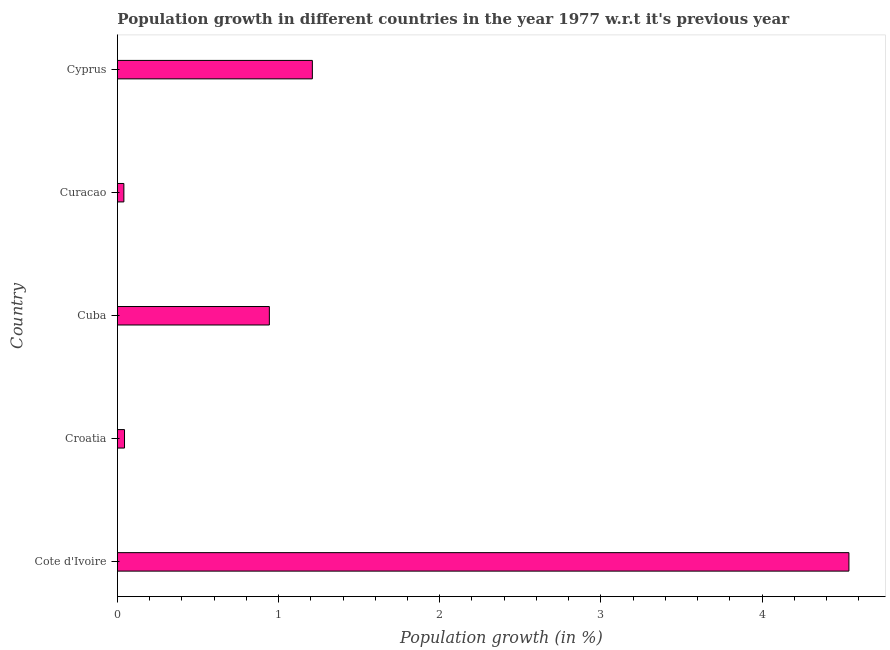Does the graph contain any zero values?
Provide a succinct answer. No. Does the graph contain grids?
Offer a terse response. No. What is the title of the graph?
Make the answer very short. Population growth in different countries in the year 1977 w.r.t it's previous year. What is the label or title of the X-axis?
Your answer should be compact. Population growth (in %). What is the label or title of the Y-axis?
Provide a succinct answer. Country. What is the population growth in Cuba?
Give a very brief answer. 0.94. Across all countries, what is the maximum population growth?
Your answer should be very brief. 4.54. Across all countries, what is the minimum population growth?
Ensure brevity in your answer.  0.04. In which country was the population growth maximum?
Offer a very short reply. Cote d'Ivoire. In which country was the population growth minimum?
Make the answer very short. Curacao. What is the sum of the population growth?
Ensure brevity in your answer.  6.78. What is the difference between the population growth in Croatia and Cyprus?
Ensure brevity in your answer.  -1.17. What is the average population growth per country?
Your answer should be compact. 1.35. What is the median population growth?
Give a very brief answer. 0.94. What is the ratio of the population growth in Cote d'Ivoire to that in Cuba?
Your answer should be very brief. 4.81. Is the difference between the population growth in Cuba and Cyprus greater than the difference between any two countries?
Make the answer very short. No. What is the difference between the highest and the second highest population growth?
Ensure brevity in your answer.  3.33. What is the difference between the highest and the lowest population growth?
Keep it short and to the point. 4.5. In how many countries, is the population growth greater than the average population growth taken over all countries?
Ensure brevity in your answer.  1. How many bars are there?
Offer a terse response. 5. Are all the bars in the graph horizontal?
Provide a short and direct response. Yes. How many countries are there in the graph?
Keep it short and to the point. 5. What is the difference between two consecutive major ticks on the X-axis?
Give a very brief answer. 1. Are the values on the major ticks of X-axis written in scientific E-notation?
Give a very brief answer. No. What is the Population growth (in %) of Cote d'Ivoire?
Your answer should be compact. 4.54. What is the Population growth (in %) of Croatia?
Offer a terse response. 0.04. What is the Population growth (in %) in Cuba?
Keep it short and to the point. 0.94. What is the Population growth (in %) in Curacao?
Give a very brief answer. 0.04. What is the Population growth (in %) of Cyprus?
Your response must be concise. 1.21. What is the difference between the Population growth (in %) in Cote d'Ivoire and Croatia?
Offer a very short reply. 4.49. What is the difference between the Population growth (in %) in Cote d'Ivoire and Cuba?
Offer a very short reply. 3.6. What is the difference between the Population growth (in %) in Cote d'Ivoire and Curacao?
Offer a terse response. 4.5. What is the difference between the Population growth (in %) in Cote d'Ivoire and Cyprus?
Your response must be concise. 3.33. What is the difference between the Population growth (in %) in Croatia and Cuba?
Make the answer very short. -0.9. What is the difference between the Population growth (in %) in Croatia and Curacao?
Keep it short and to the point. 0. What is the difference between the Population growth (in %) in Croatia and Cyprus?
Your answer should be very brief. -1.17. What is the difference between the Population growth (in %) in Cuba and Curacao?
Provide a succinct answer. 0.9. What is the difference between the Population growth (in %) in Cuba and Cyprus?
Your response must be concise. -0.27. What is the difference between the Population growth (in %) in Curacao and Cyprus?
Provide a succinct answer. -1.17. What is the ratio of the Population growth (in %) in Cote d'Ivoire to that in Croatia?
Provide a short and direct response. 102.83. What is the ratio of the Population growth (in %) in Cote d'Ivoire to that in Cuba?
Offer a terse response. 4.81. What is the ratio of the Population growth (in %) in Cote d'Ivoire to that in Curacao?
Give a very brief answer. 113.04. What is the ratio of the Population growth (in %) in Cote d'Ivoire to that in Cyprus?
Provide a succinct answer. 3.75. What is the ratio of the Population growth (in %) in Croatia to that in Cuba?
Offer a very short reply. 0.05. What is the ratio of the Population growth (in %) in Croatia to that in Curacao?
Give a very brief answer. 1.1. What is the ratio of the Population growth (in %) in Croatia to that in Cyprus?
Provide a succinct answer. 0.04. What is the ratio of the Population growth (in %) in Cuba to that in Curacao?
Your answer should be very brief. 23.48. What is the ratio of the Population growth (in %) in Cuba to that in Cyprus?
Give a very brief answer. 0.78. What is the ratio of the Population growth (in %) in Curacao to that in Cyprus?
Offer a terse response. 0.03. 